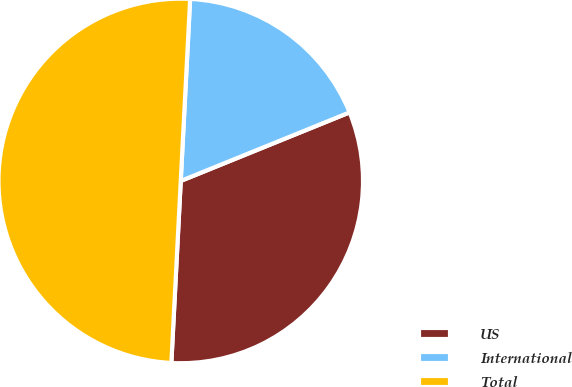Convert chart. <chart><loc_0><loc_0><loc_500><loc_500><pie_chart><fcel>US<fcel>International<fcel>Total<nl><fcel>31.96%<fcel>18.04%<fcel>50.0%<nl></chart> 